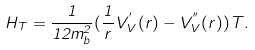Convert formula to latex. <formula><loc_0><loc_0><loc_500><loc_500>H _ { T } = \frac { 1 } { 1 2 m _ { b } ^ { 2 } } ( \frac { 1 } { r } V _ { V } ^ { ^ { \prime } } ( r ) - V _ { V } ^ { ^ { \prime \prime } } ( r ) ) T .</formula> 